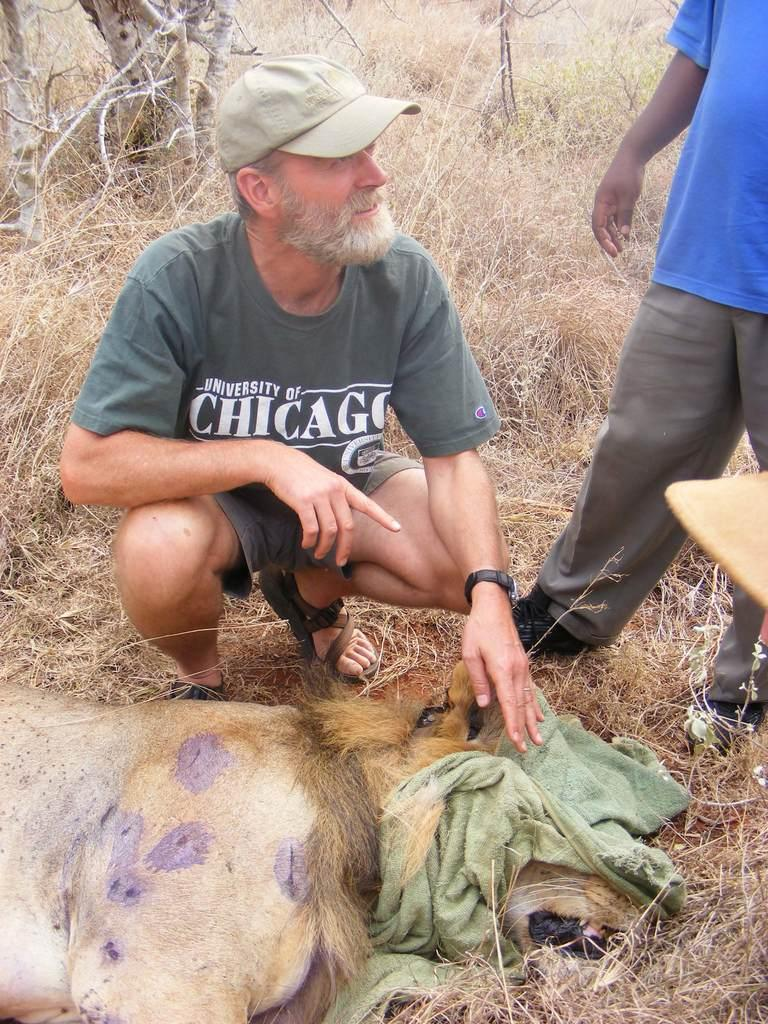What is the main subject of the image? There is a person sitting at the center of the image. What is the person sitting on? The person is sitting on a lion. Are there any other people in the image? Yes, there is another person on the right side of the image. What type of environment is depicted in the image? Grass and trees are visible in the image, suggesting a natural setting. What type of whip is being used by the person sitting on the lion? There is no whip present in the image. What is the current state of the lion in the image? The image is a still photograph, so the lion's state cannot be described as a "current state." 